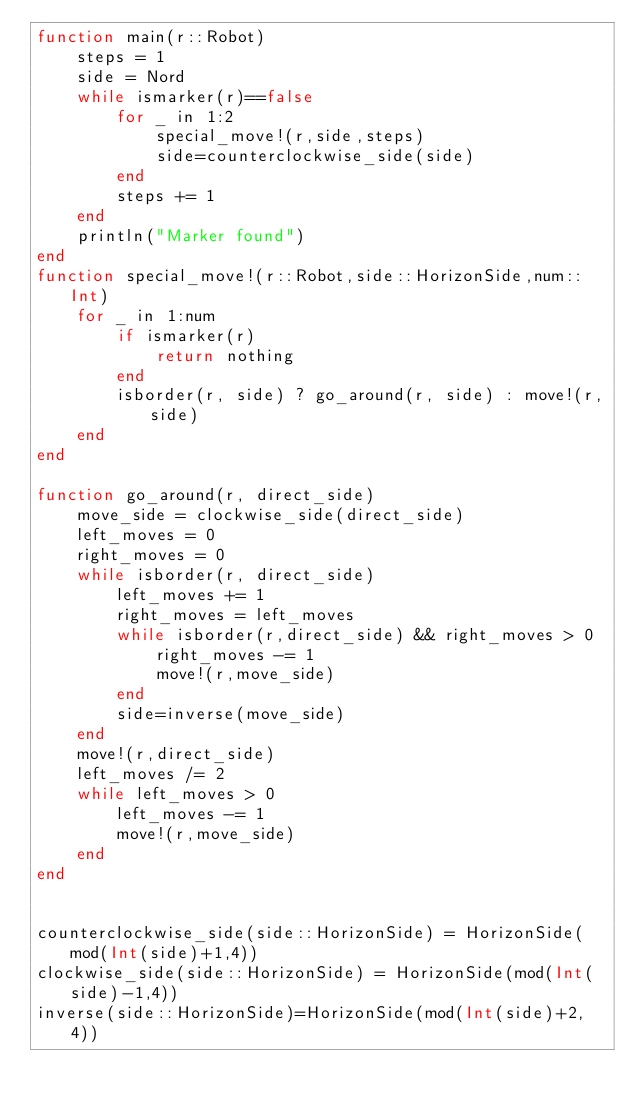<code> <loc_0><loc_0><loc_500><loc_500><_Julia_>function main(r::Robot)
    steps = 1
    side = Nord
    while ismarker(r)==false
        for _ in 1:2
            special_move!(r,side,steps)
            side=counterclockwise_side(side)
        end
        steps += 1
    end
    println("Marker found")
end
function special_move!(r::Robot,side::HorizonSide,num::Int)
    for _ in 1:num
        if ismarker(r)
            return nothing
        end
        isborder(r, side) ? go_around(r, side) : move!(r,side)
    end
end

function go_around(r, direct_side)
    move_side = clockwise_side(direct_side)
    left_moves = 0
    right_moves = 0
    while isborder(r, direct_side)
        left_moves += 1
        right_moves = left_moves
        while isborder(r,direct_side) && right_moves > 0
            right_moves -= 1
            move!(r,move_side)
        end
        side=inverse(move_side)
    end
    move!(r,direct_side)
    left_moves /= 2
    while left_moves > 0
        left_moves -= 1
        move!(r,move_side)
    end
end


counterclockwise_side(side::HorizonSide) = HorizonSide(mod(Int(side)+1,4))
clockwise_side(side::HorizonSide) = HorizonSide(mod(Int(side)-1,4))
inverse(side::HorizonSide)=HorizonSide(mod(Int(side)+2, 4))
</code> 